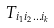Convert formula to latex. <formula><loc_0><loc_0><loc_500><loc_500>T _ { i _ { 1 } i _ { 2 } \dots i _ { k } }</formula> 